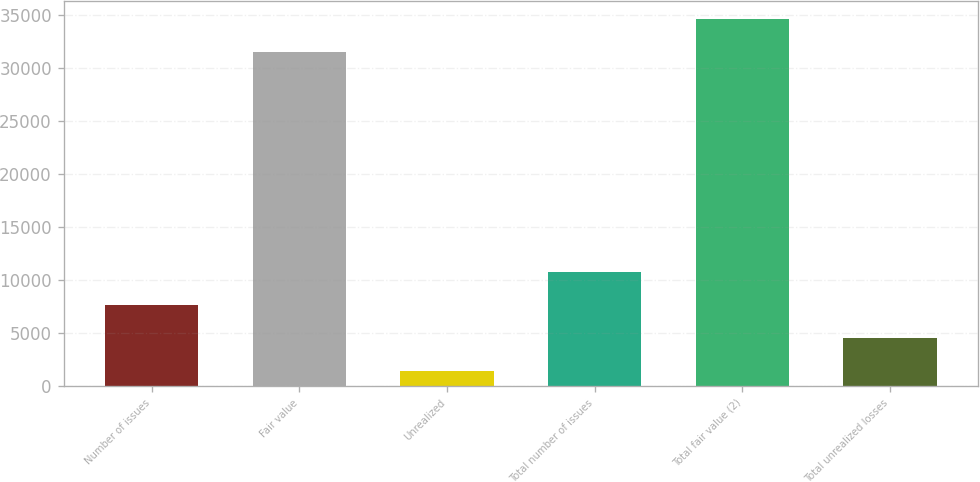<chart> <loc_0><loc_0><loc_500><loc_500><bar_chart><fcel>Number of issues<fcel>Fair value<fcel>Unrealized<fcel>Total number of issues<fcel>Total fair value (2)<fcel>Total unrealized losses<nl><fcel>7629.8<fcel>31489<fcel>1391<fcel>10749.2<fcel>34608.4<fcel>4510.4<nl></chart> 